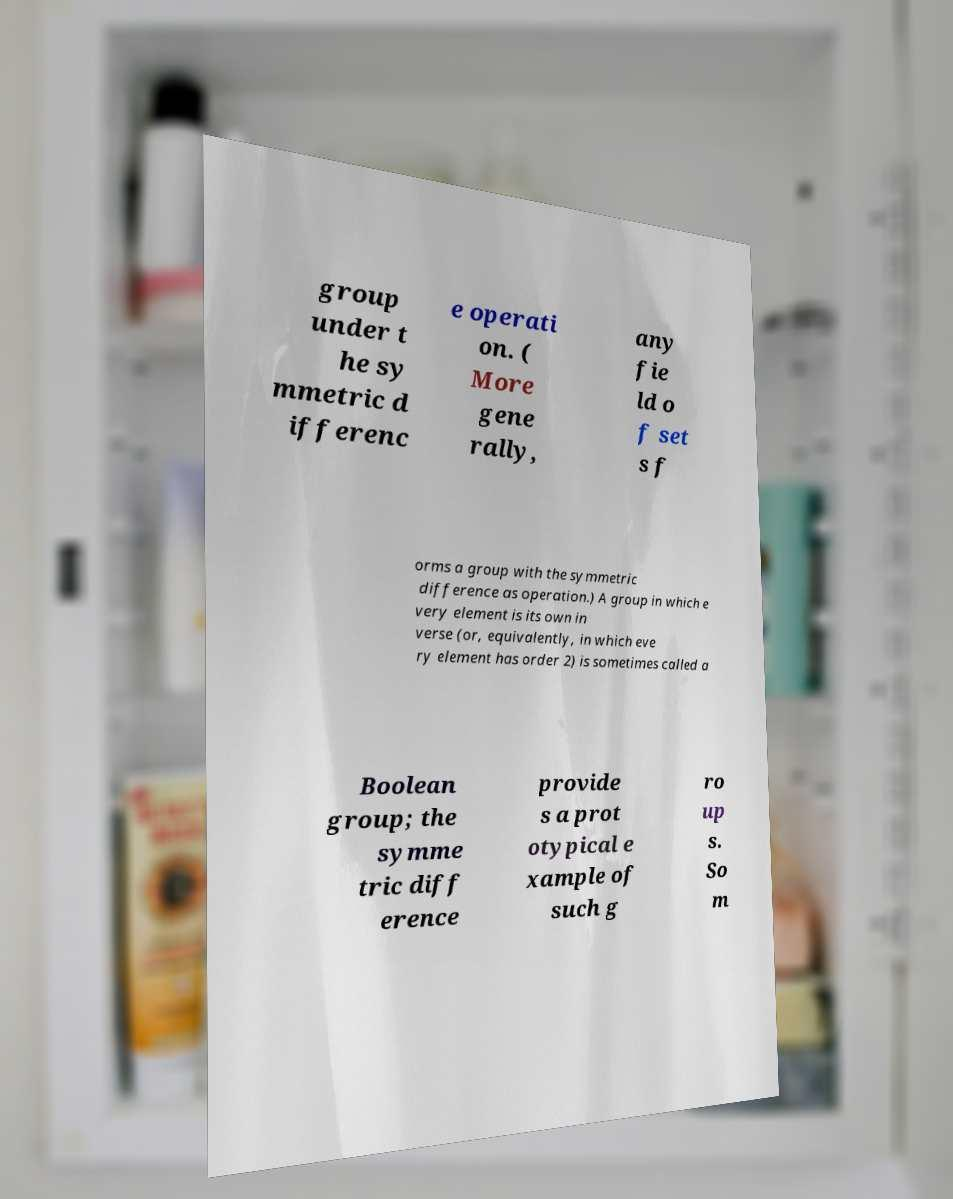Can you accurately transcribe the text from the provided image for me? group under t he sy mmetric d ifferenc e operati on. ( More gene rally, any fie ld o f set s f orms a group with the symmetric difference as operation.) A group in which e very element is its own in verse (or, equivalently, in which eve ry element has order 2) is sometimes called a Boolean group; the symme tric diff erence provide s a prot otypical e xample of such g ro up s. So m 